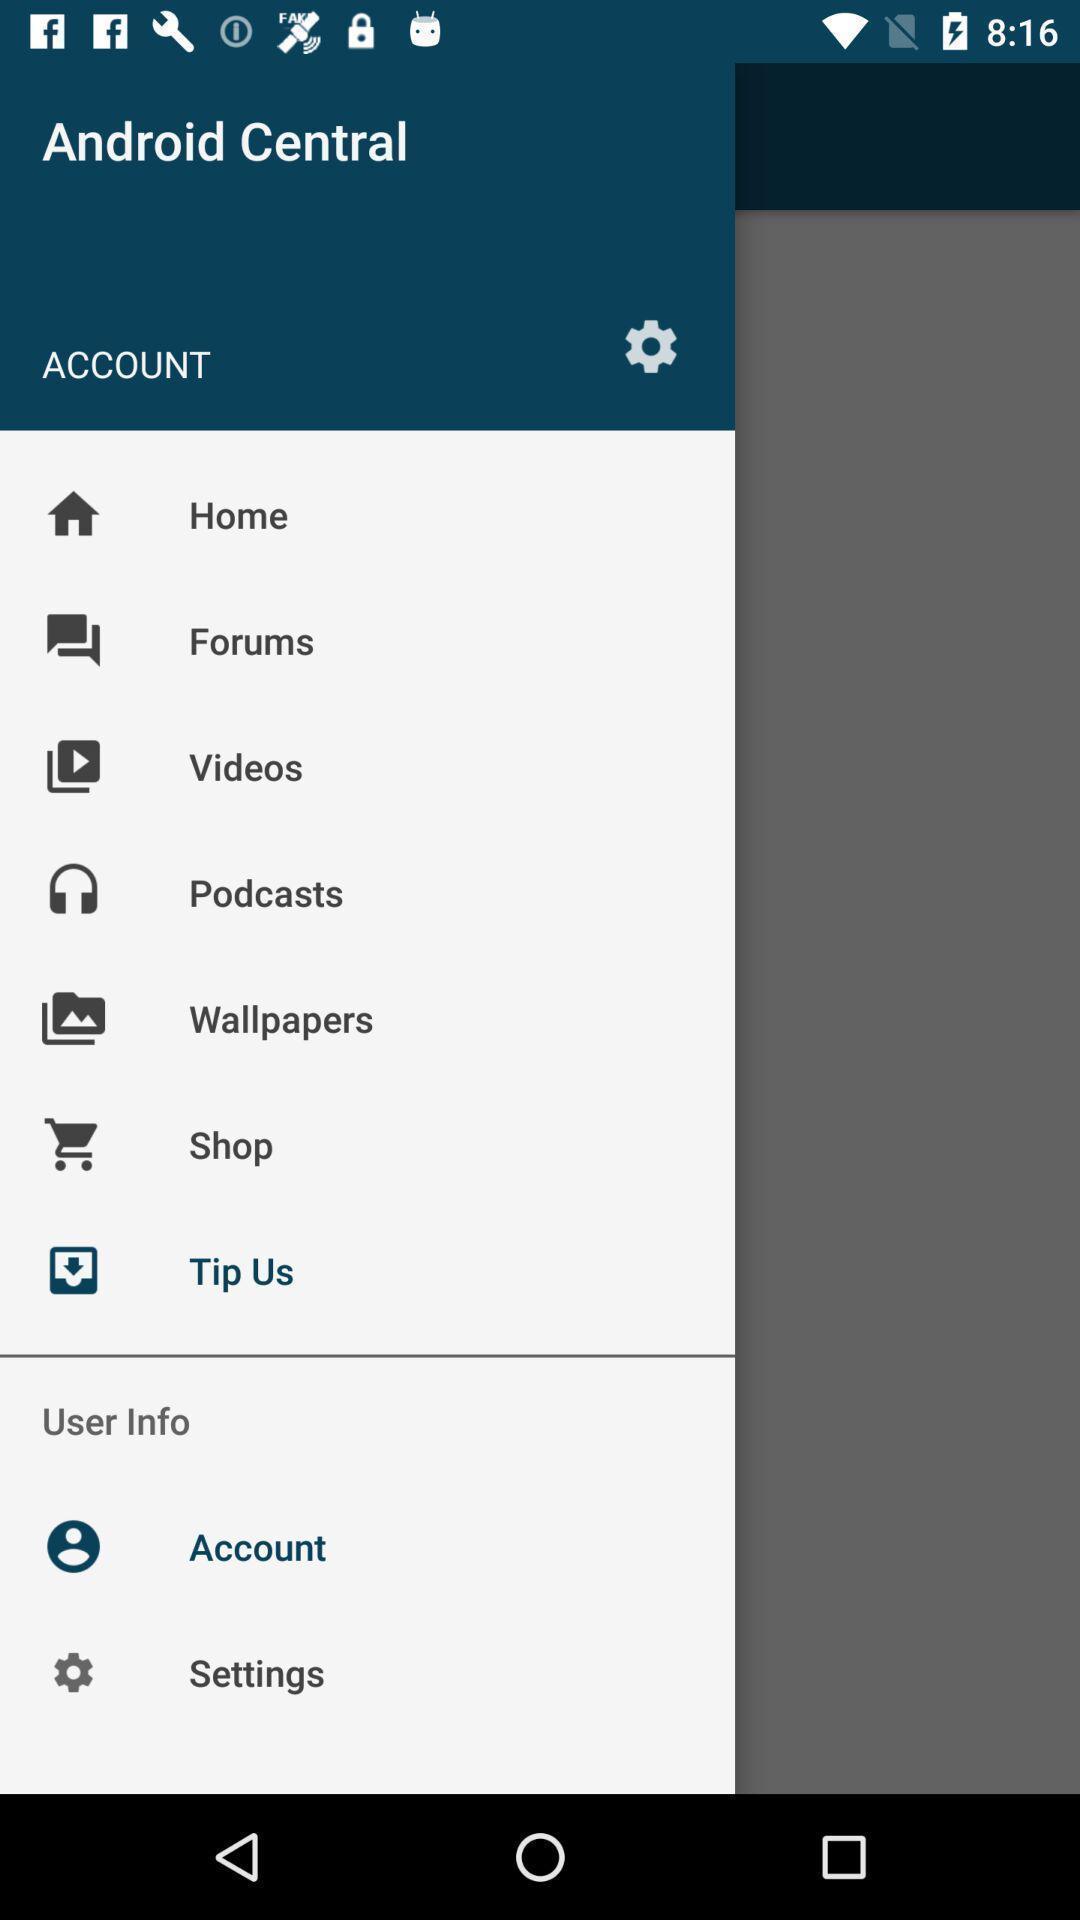What details can you identify in this image? Page displaying list of options. 